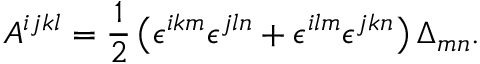<formula> <loc_0><loc_0><loc_500><loc_500>A ^ { i j k l } = \frac { 1 } { 2 } \left ( \epsilon ^ { i k m } \epsilon ^ { j \ln } + \epsilon ^ { i l m } \epsilon ^ { j k n } \right ) \Delta _ { m n } .</formula> 